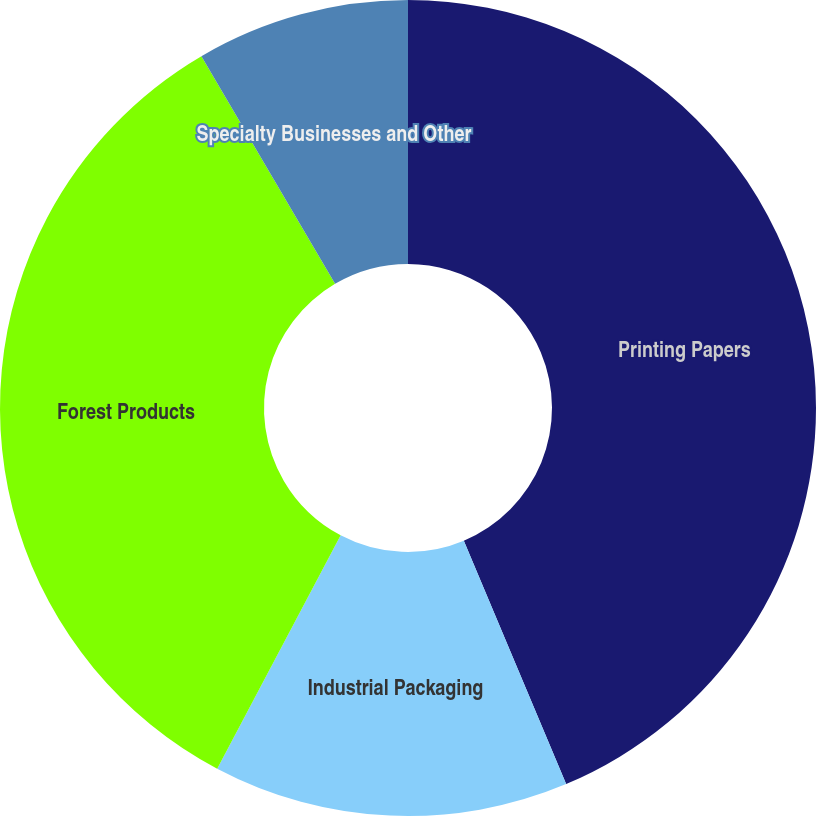<chart> <loc_0><loc_0><loc_500><loc_500><pie_chart><fcel>Printing Papers<fcel>Industrial Packaging<fcel>Forest Products<fcel>Specialty Businesses and Other<nl><fcel>43.66%<fcel>14.08%<fcel>33.8%<fcel>8.45%<nl></chart> 